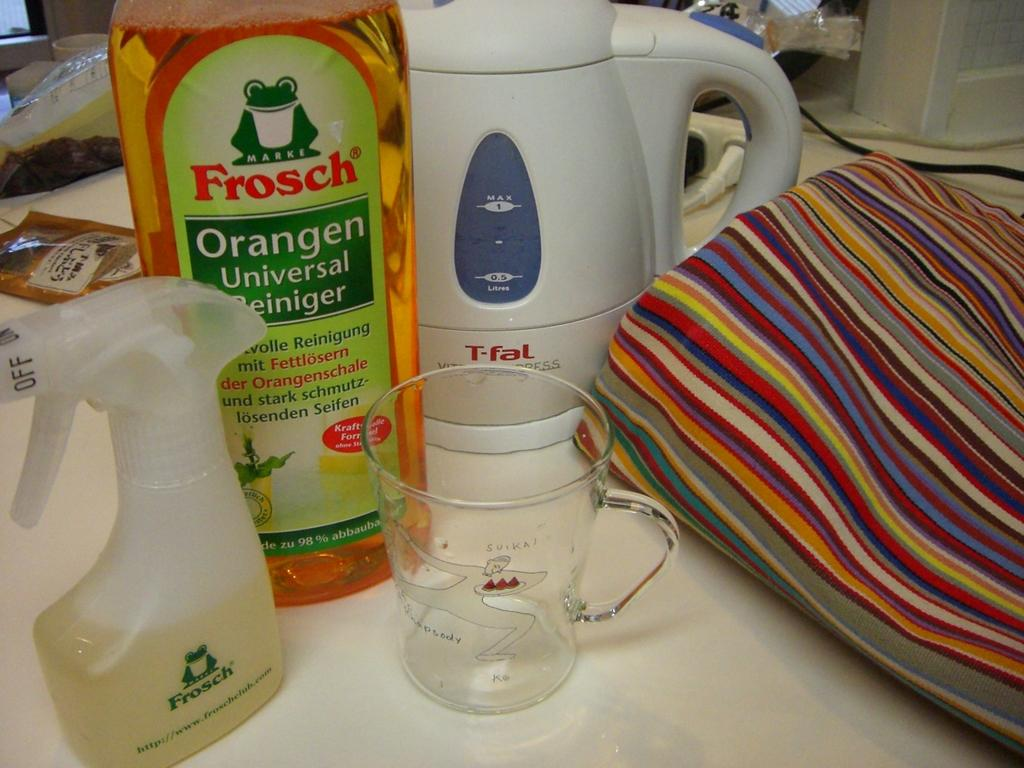<image>
Render a clear and concise summary of the photo. A Frosch spray bottle and refill container are among the many items on the table. 